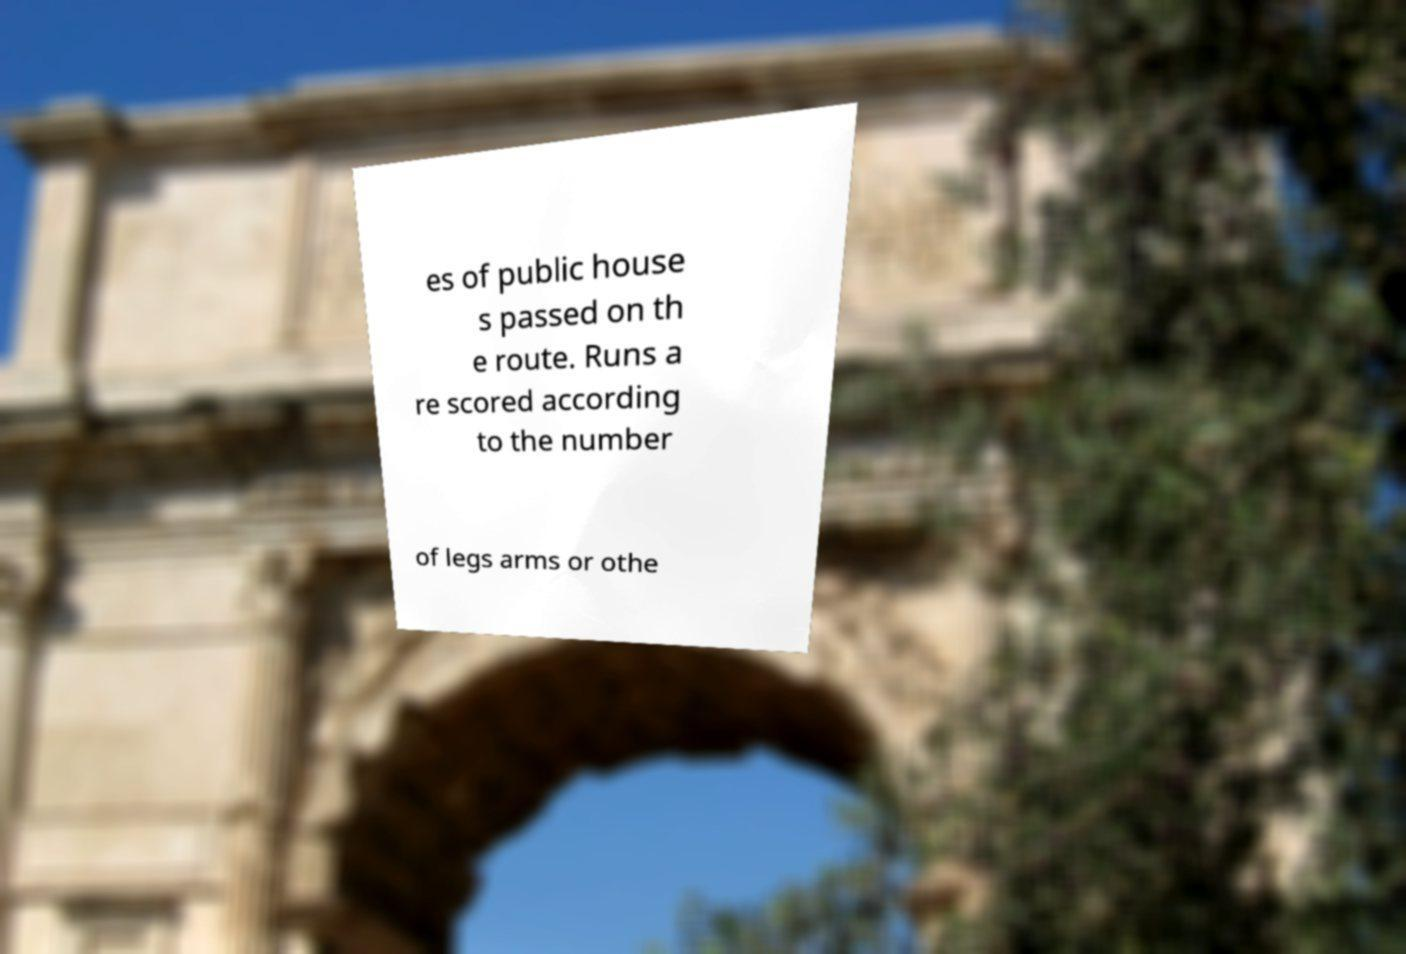There's text embedded in this image that I need extracted. Can you transcribe it verbatim? es of public house s passed on th e route. Runs a re scored according to the number of legs arms or othe 